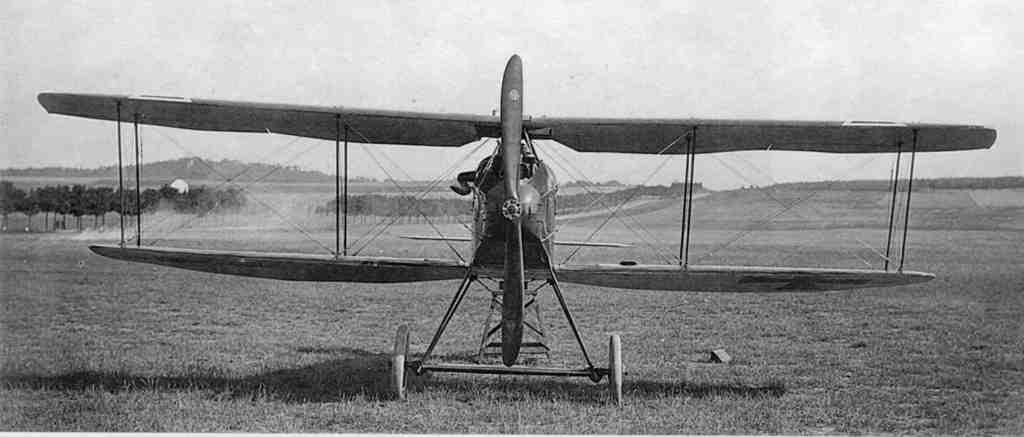How would you summarize this image in a sentence or two? In the image we can see there is a helicopter standing on the ground and the ground is covered with grass. Behind there are lot of trees and there are hills. There is a clear sky on the top and the image is in black and white colour. 